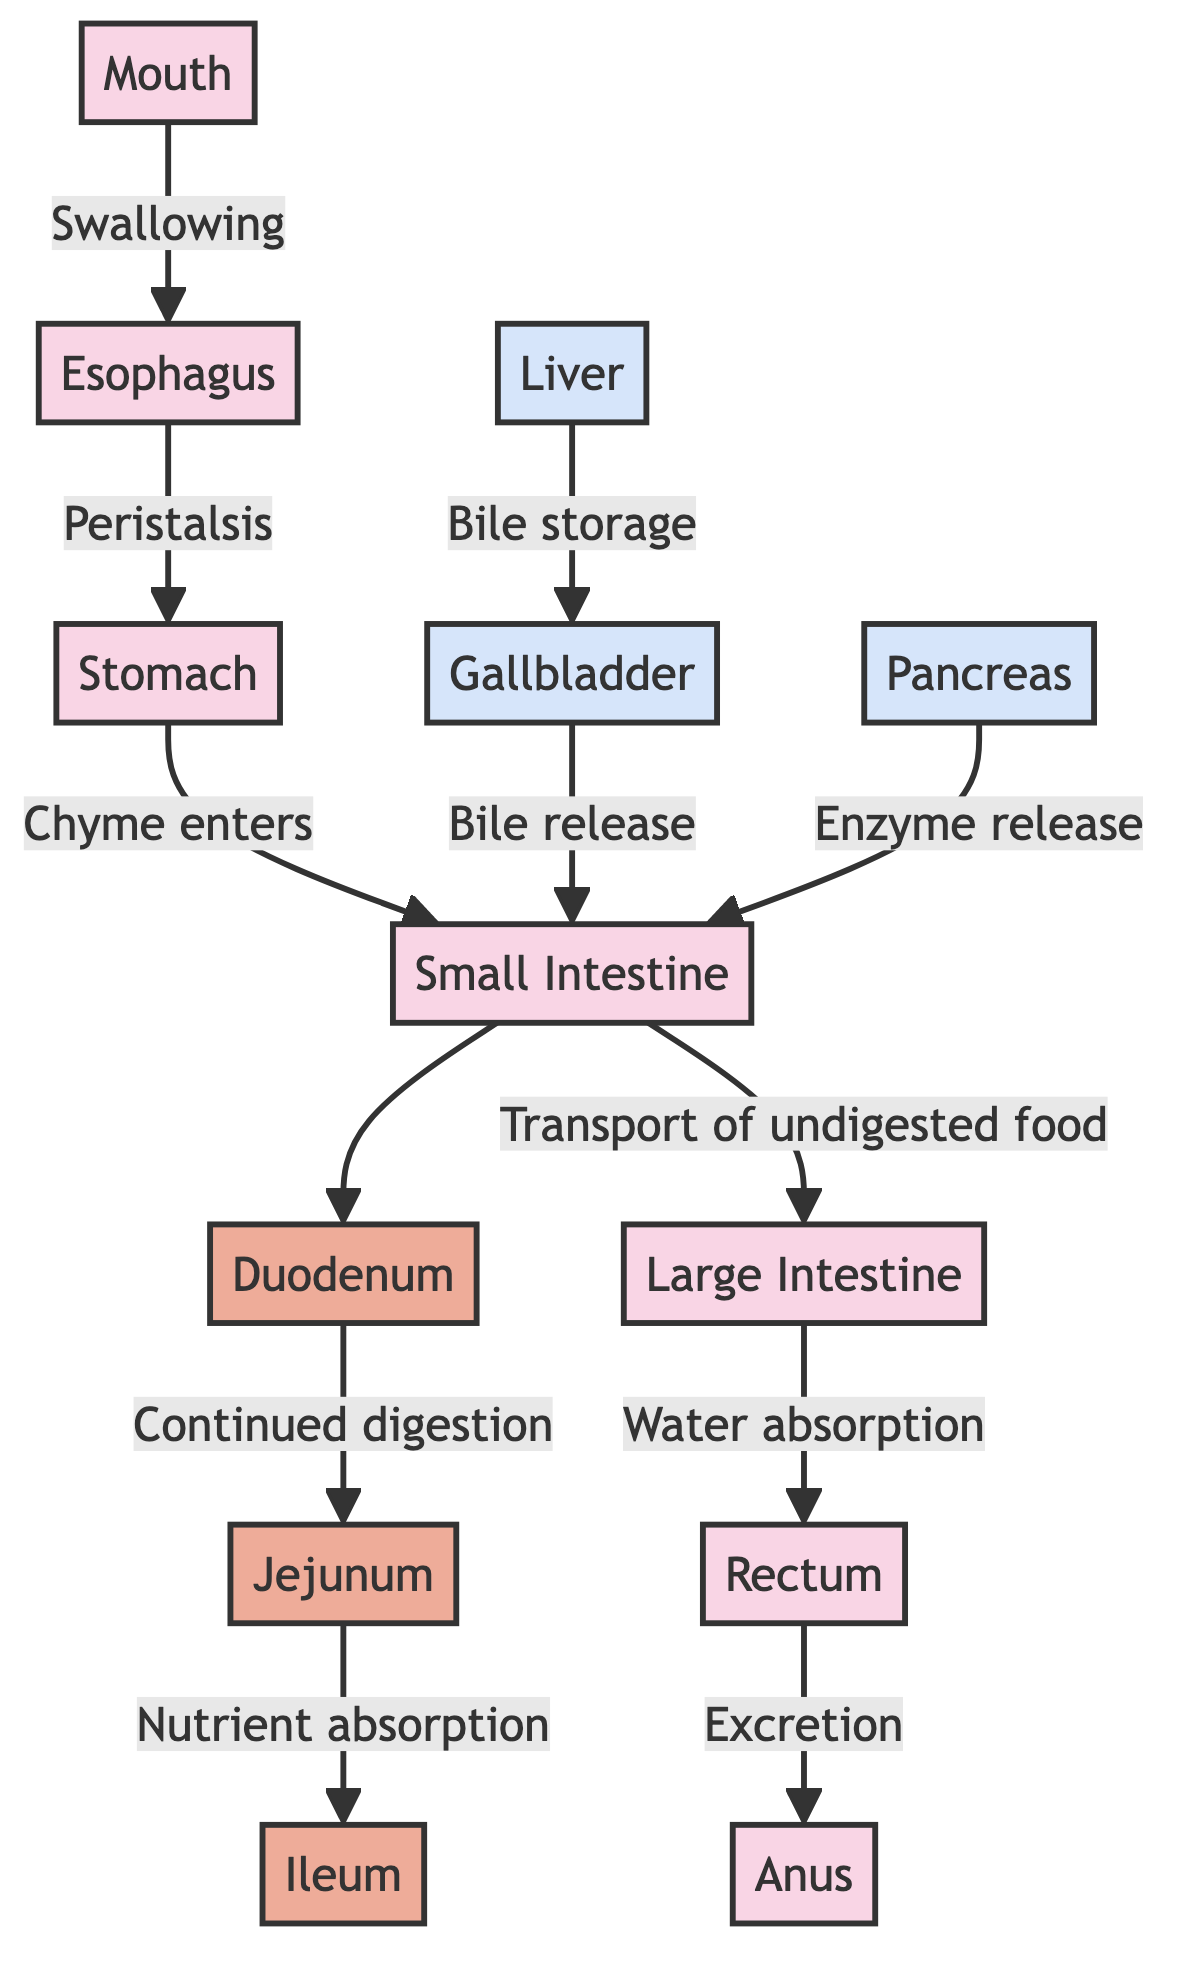What is the first organ involved in the digestive process? The diagram shows an arrow leading from "Mouth" to "Esophagus," indicating that digestion starts in the mouth.
Answer: Mouth How many segments are there in the small intestine? The small intestine is divided into three specific segments: Duodenum, Jejunum, and Ileum, as illustrated in the diagram.
Answer: 3 What process occurs in the jejunum? The diagram indicates that the jejunum is responsible for "Nutrient absorption," which is explicitly stated connected to the ileum.
Answer: Nutrient absorption Which organ is responsible for bile storage? The diagram shows a direct connection from "Liver" to "Gallbladder," indicating that the liver stores bile which is released by the gallbladder.
Answer: Gallbladder Which organ excretes waste? The diagram specifies a flow from "Rectum" to "Anus," indicating that the anus is the final part of the digestive system responsible for waste excretion.
Answer: Anus What is the relationship between the pancreas and the small intestine? The diagram shows that the pancreas is linked to the small intestine with the label "Enzyme release," indicating that enzymes from the pancreas aid in digestion within the small intestine.
Answer: Enzyme release What happens to undigested food after the small intestine? According to the diagram, undigested food is transported from the small intestine to the large intestine, as indicated by the arrow.
Answer: Transport of undigested food How does the stomach process food before it reaches the small intestine? The diagram illustrates that chyme enters the small intestine from the stomach, indicating that this mixture of partially digested food is what moves forward in digestion.
Answer: Chyme enters What is absorbed in the large intestine? The diagram specifies that "Water absorption" occurs in the large intestine, indicating its role in absorbing nutrients that were not absorbed earlier.
Answer: Water absorption 